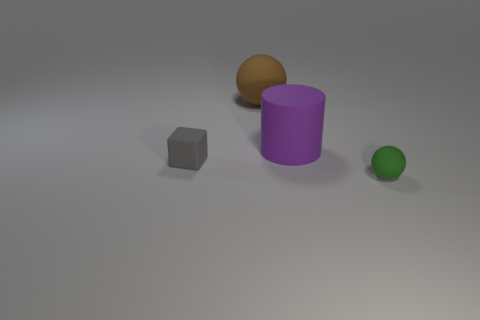There is a tiny object to the right of the cube; what shape is it?
Give a very brief answer. Sphere. Is there a brown thing made of the same material as the green thing?
Make the answer very short. Yes. Does the purple rubber object have the same size as the block?
Provide a short and direct response. No. What number of spheres are either gray rubber things or brown matte things?
Your answer should be very brief. 1. How many other tiny objects are the same shape as the small green rubber thing?
Offer a very short reply. 0. Is the number of big matte balls on the right side of the big purple object greater than the number of purple rubber cylinders that are left of the big brown sphere?
Offer a very short reply. No. Does the tiny thing to the right of the purple cylinder have the same color as the big cylinder?
Keep it short and to the point. No. The purple cylinder has what size?
Keep it short and to the point. Large. There is a brown object that is the same size as the cylinder; what material is it?
Keep it short and to the point. Rubber. What color is the large matte cylinder to the right of the gray rubber block?
Ensure brevity in your answer.  Purple. 